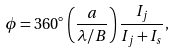<formula> <loc_0><loc_0><loc_500><loc_500>\phi = 3 6 0 ^ { \circ } \left ( \frac { a } { \lambda / B } \right ) \frac { I _ { j } } { I _ { j } + I _ { s } } ,</formula> 